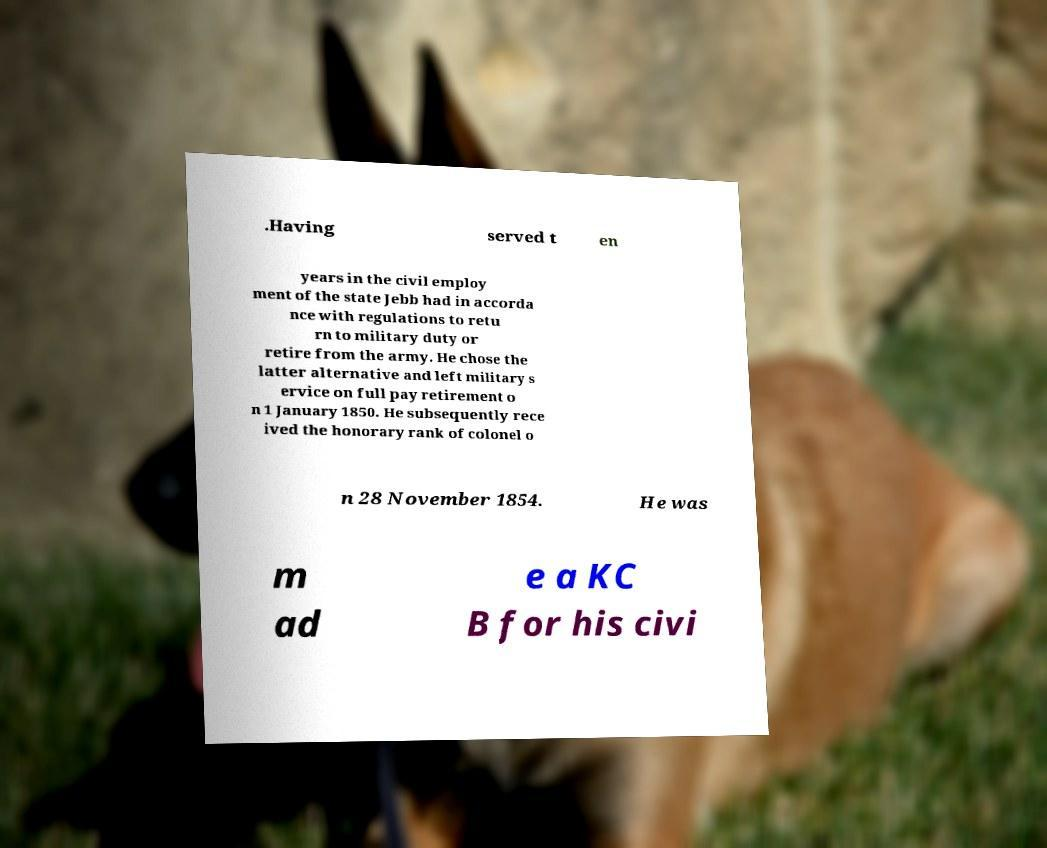What messages or text are displayed in this image? I need them in a readable, typed format. .Having served t en years in the civil employ ment of the state Jebb had in accorda nce with regulations to retu rn to military duty or retire from the army. He chose the latter alternative and left military s ervice on full pay retirement o n 1 January 1850. He subsequently rece ived the honorary rank of colonel o n 28 November 1854. He was m ad e a KC B for his civi 